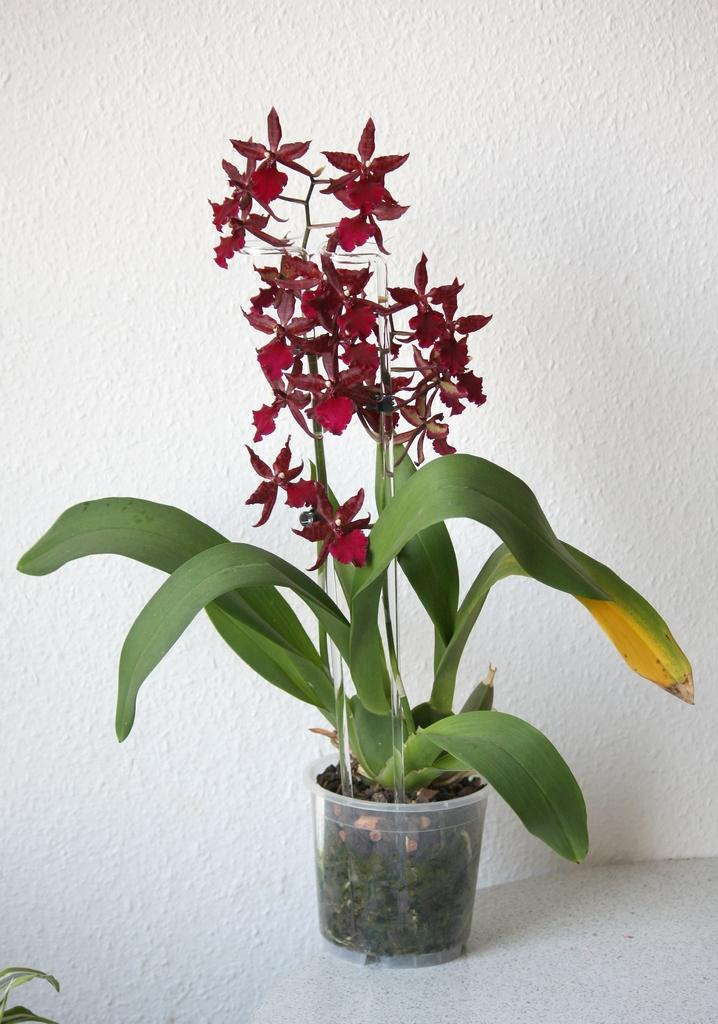What objects are present in the image? There are flower pots in the image. What can be seen in the background of the image? There is a wall in the background of the image. What type of lipstick is being used on the bell in the image? There is no bell or lipstick present in the image. 